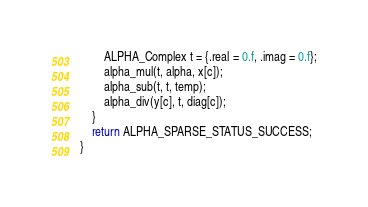<code> <loc_0><loc_0><loc_500><loc_500><_C_>
        ALPHA_Complex t = {.real = 0.f, .imag = 0.f};
        alpha_mul(t, alpha, x[c]);
        alpha_sub(t, t, temp);
        alpha_div(y[c], t, diag[c]);
    }
    return ALPHA_SPARSE_STATUS_SUCCESS;
}
</code> 